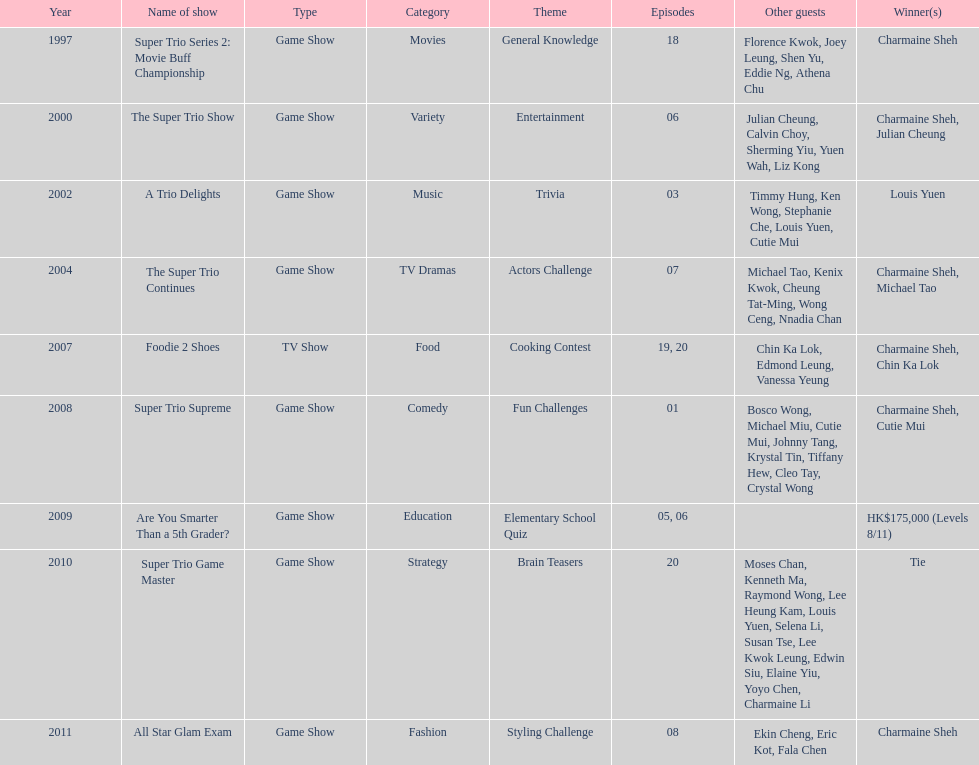How many episodes was charmaine sheh on in the variety show super trio 2: movie buff champions 18. 